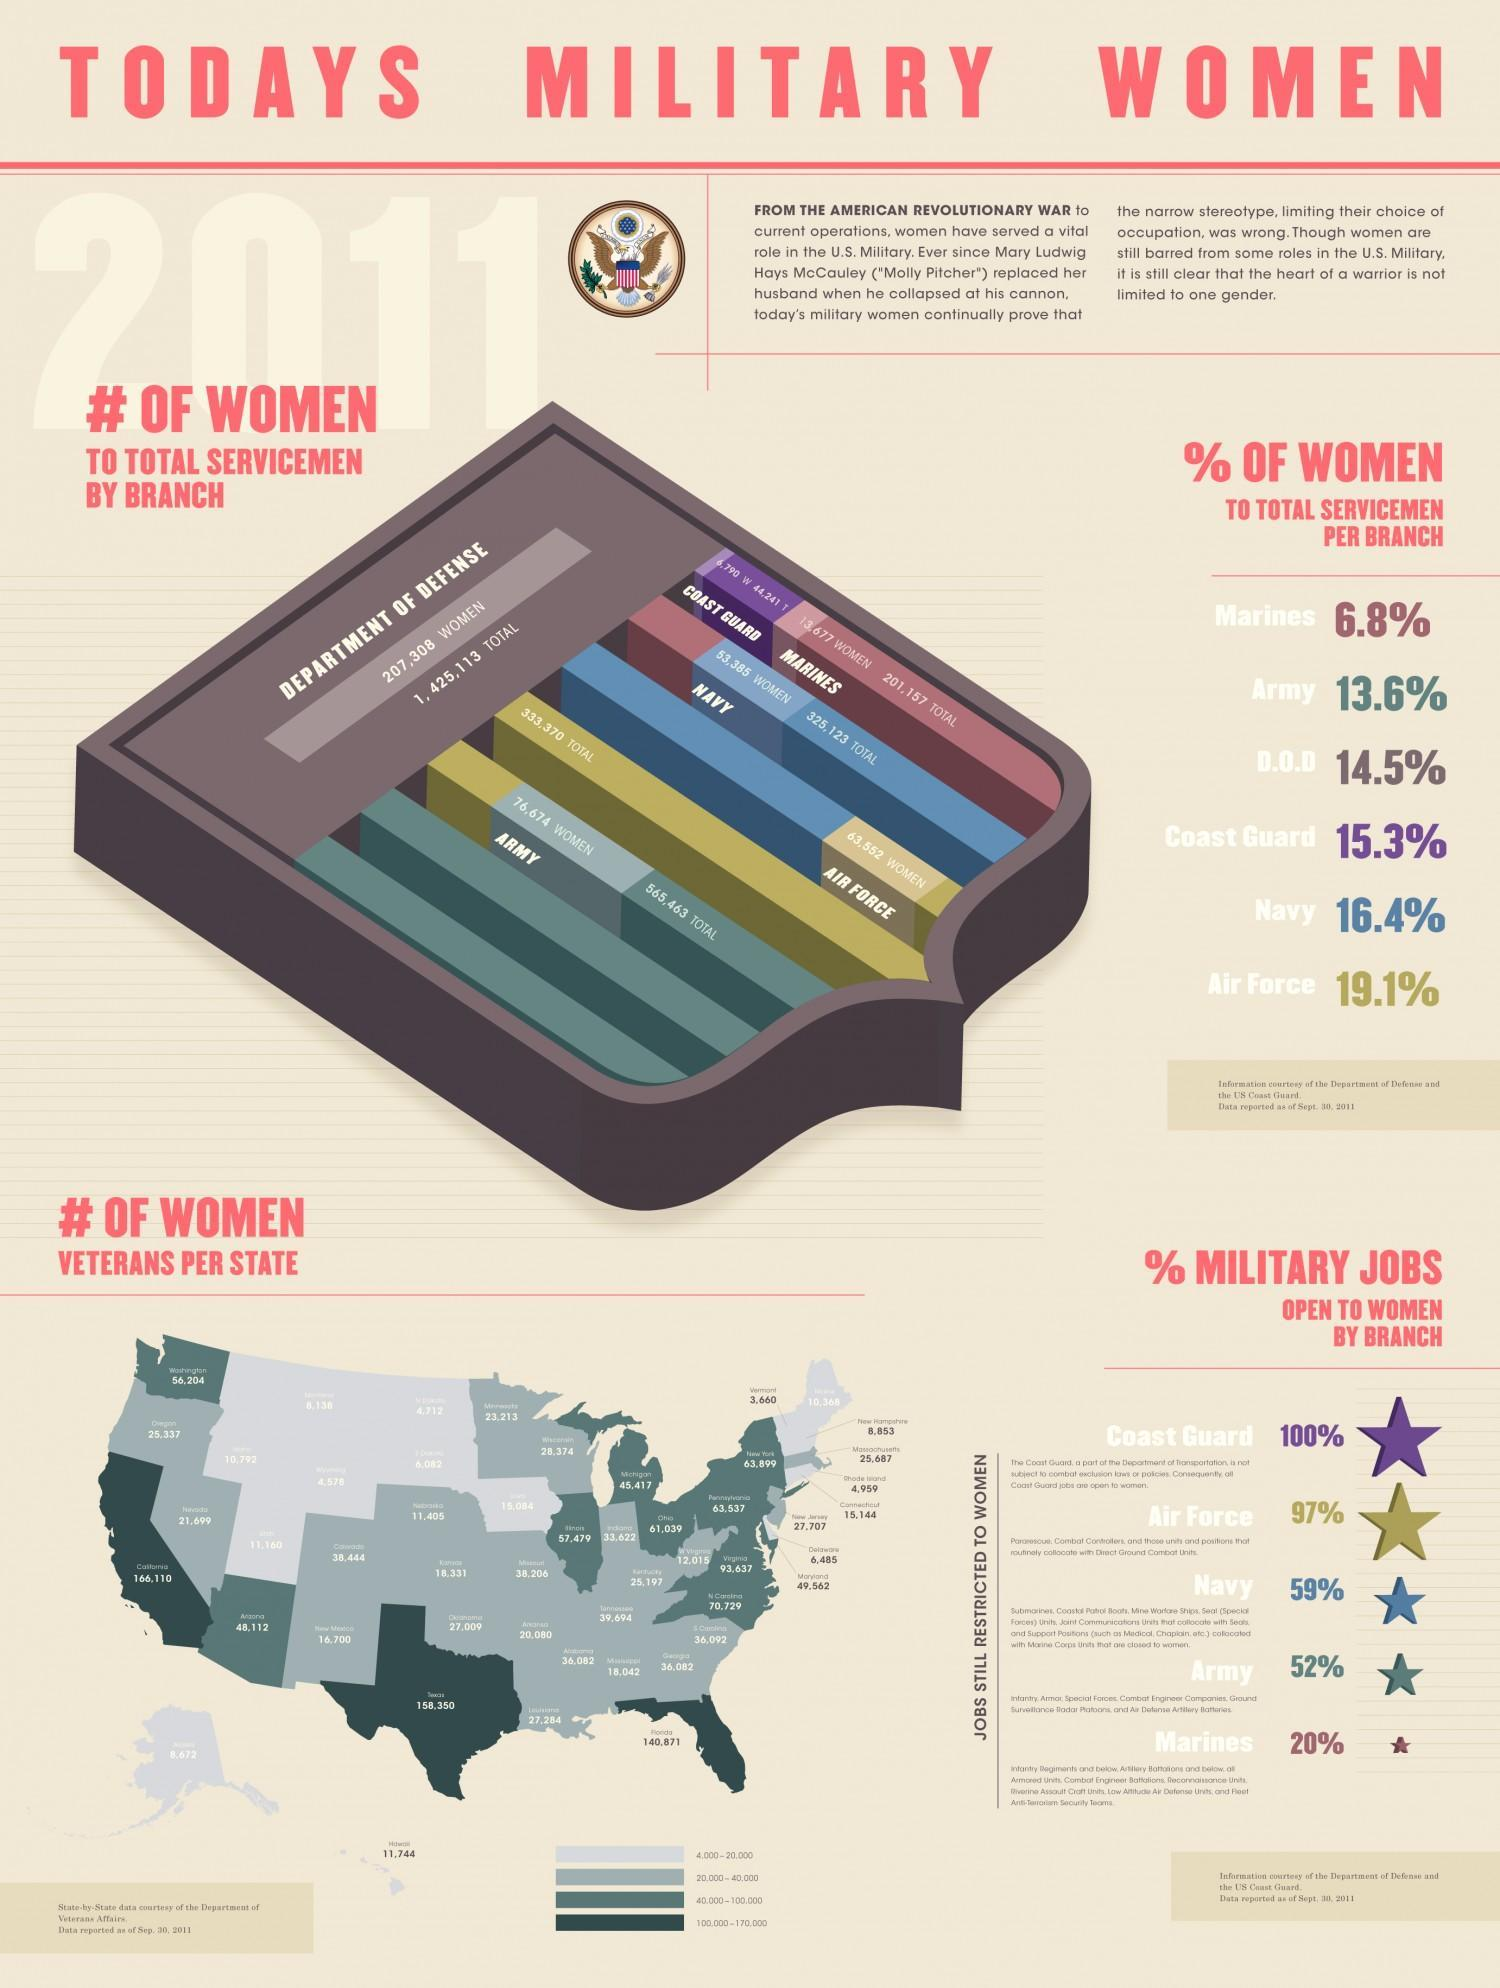In which branch of the Military are women the fourth-highest to total servicemen?
Answer the question with a short phrase. D.O.D How many states of the US have women veterans in the range 100,000-170,000? 3 In which military branch second-highest no of jobs are open to women? Air Force How many people working in the Department of Defense are men? 12,17,805 Which state of the US has the highest no of women veterans? California In which branch of the Military are women the second-highest to total servicemen? Navy What is the no of women veterans in the west-most island state of the US? 8,672 What is the percentage of women to total servicemen in the third-highest branch of military? 15.3% Which state of the US has the second-highest no of women veterans? Texas In which military branch third-highest no of jobs are open to women? Navy 